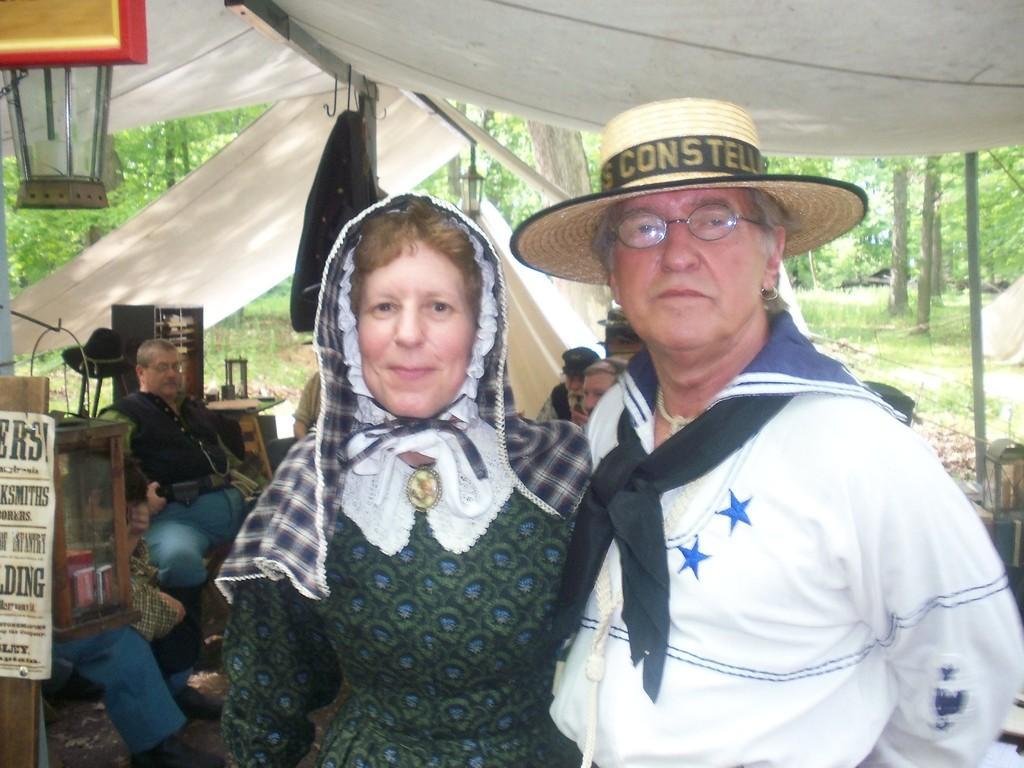Could you give a brief overview of what you see in this image? In the center of the image we can see the man and the woman standing under the tent. In the background we can also see few people sitting. Image also consists of many trees. 